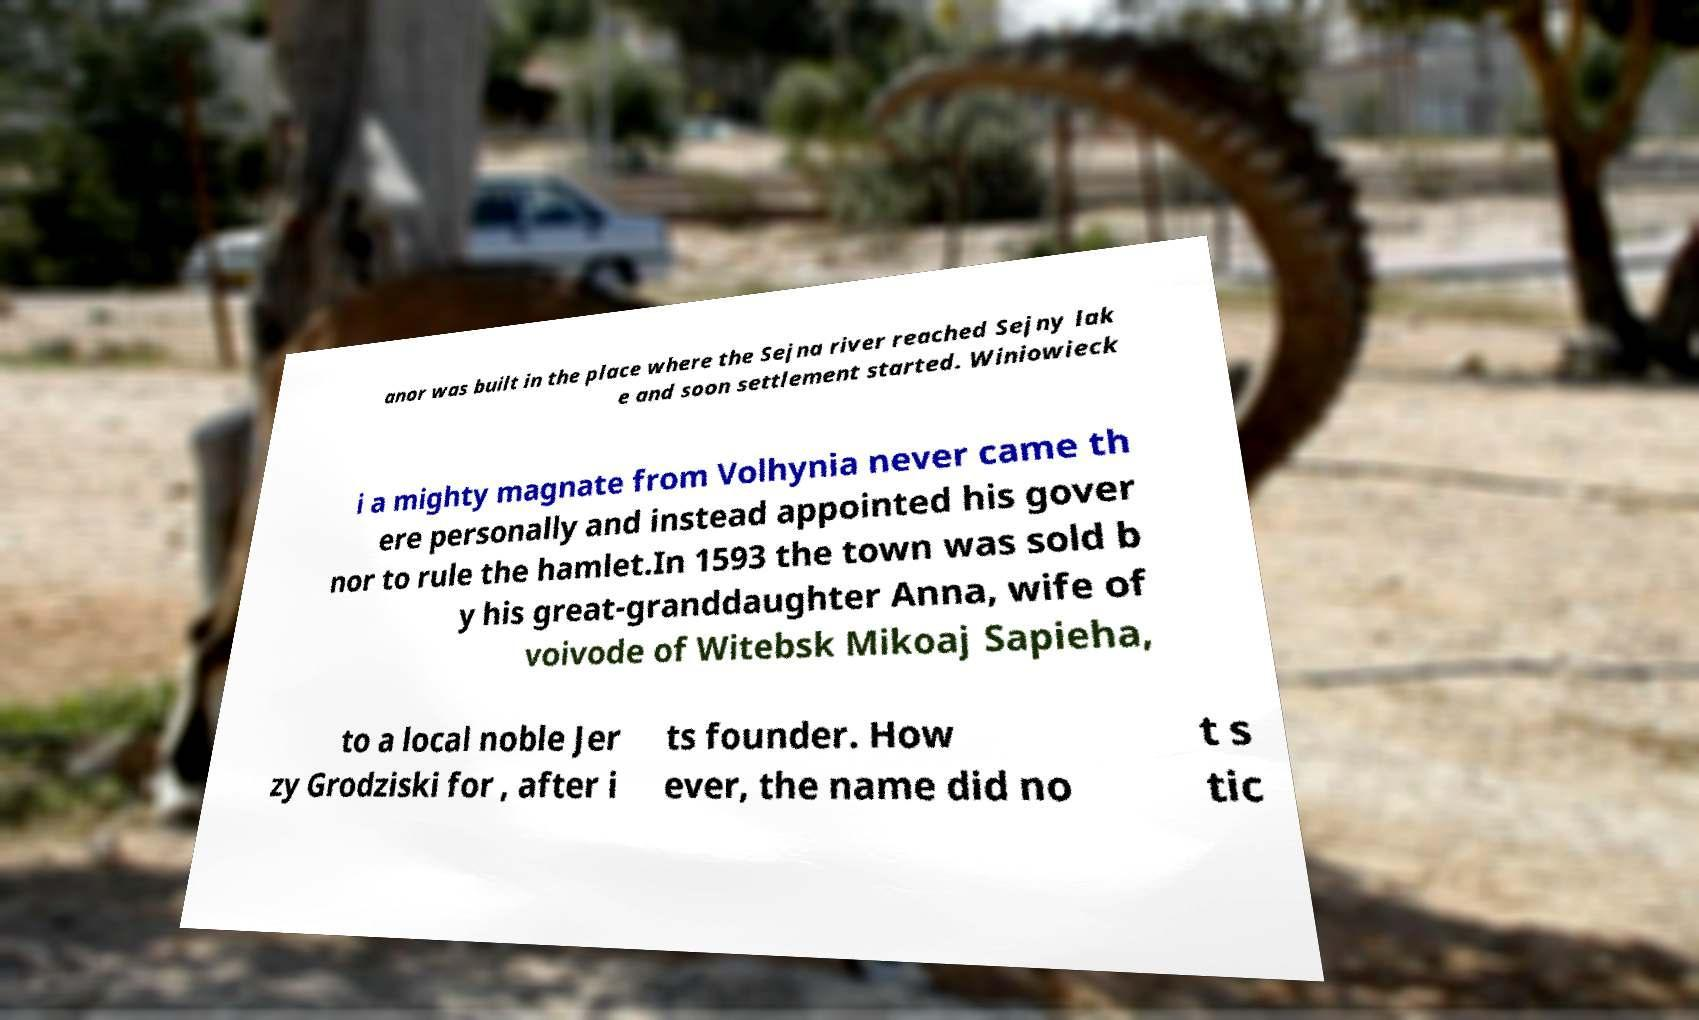For documentation purposes, I need the text within this image transcribed. Could you provide that? anor was built in the place where the Sejna river reached Sejny lak e and soon settlement started. Winiowieck i a mighty magnate from Volhynia never came th ere personally and instead appointed his gover nor to rule the hamlet.In 1593 the town was sold b y his great-granddaughter Anna, wife of voivode of Witebsk Mikoaj Sapieha, to a local noble Jer zy Grodziski for , after i ts founder. How ever, the name did no t s tic 